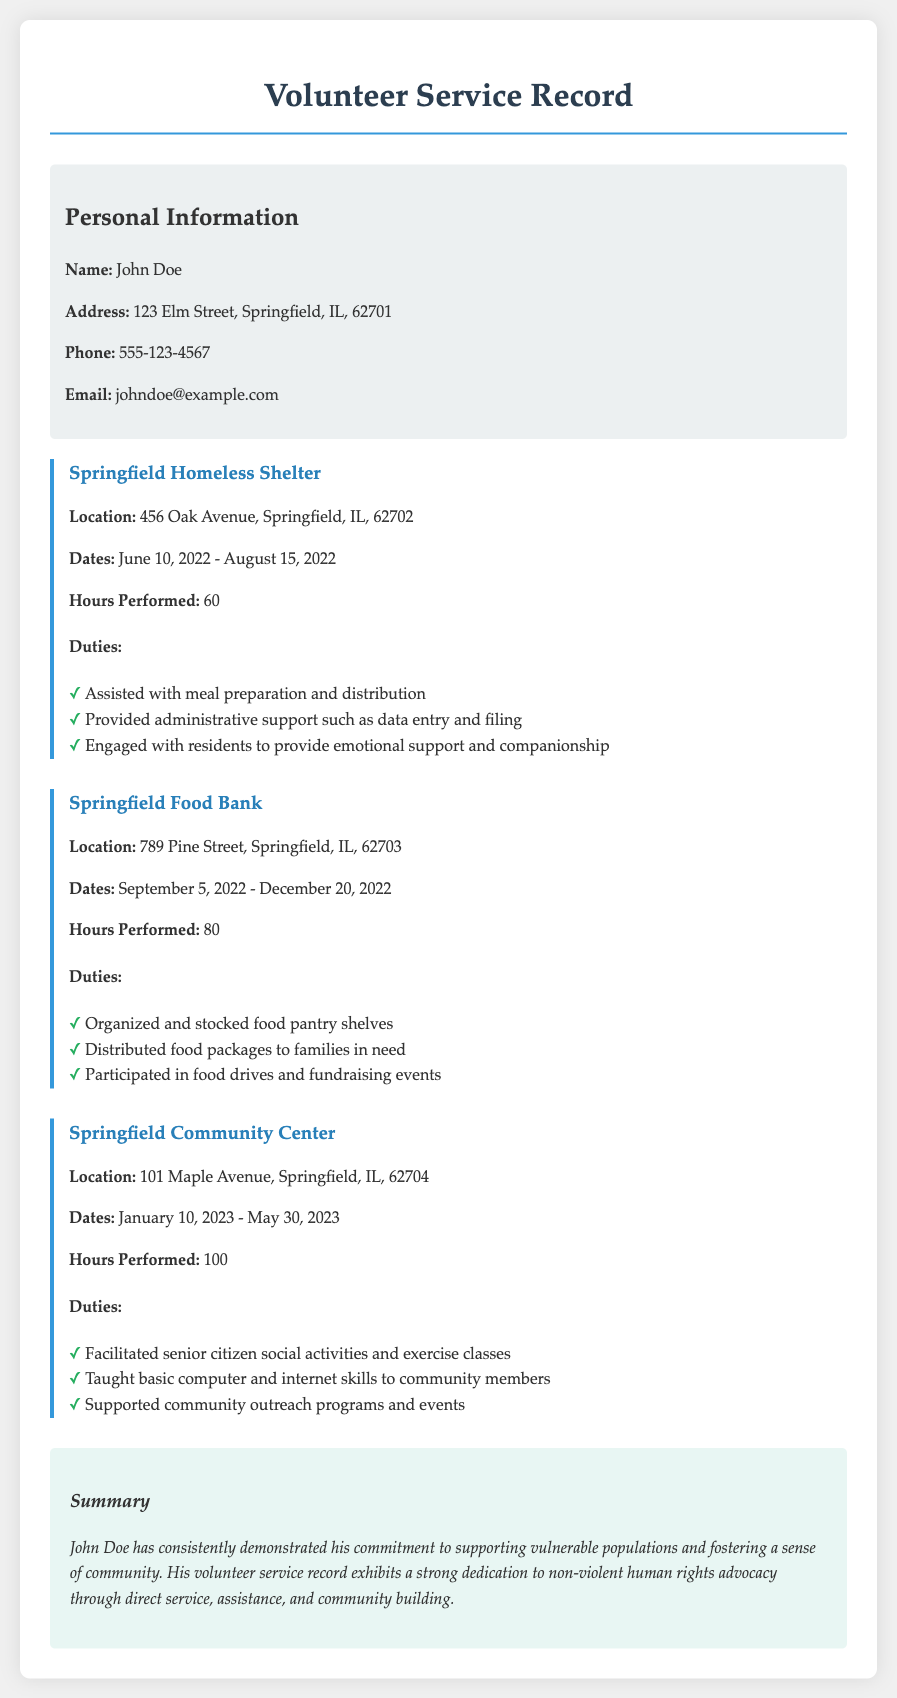What is the name of the volunteer? The name of the volunteer is stated in the personal information section of the document.
Answer: John Doe What is the address of the volunteer? The address is found in the personal information section and provides the volunteer's home location.
Answer: 123 Elm Street, Springfield, IL, 62701 How many hours were served at the Springfield Food Bank? The document states the number of hours served specifically at the Springfield Food Bank.
Answer: 80 What was one duty performed at the Springfield Homeless Shelter? The document lists specific duties performed at the Springfield Homeless Shelter, requiring identification of at least one.
Answer: Assisted with meal preparation and distribution What were the dates of service at the Springfield Community Center? The document provides the start and end dates for service at the Springfield Community Center.
Answer: January 10, 2023 - May 30, 2023 How many total hours were volunteered across all entries? This calculation involves summing the hours served at each service entry: 60 + 80 + 100.
Answer: 240 What type of supporting activities were facilitated by John Doe? This information is found in the duties listed under the Springfield Community Center service entry.
Answer: Senior citizen social activities and exercise classes What is the focus of John Doe's volunteer efforts, as summarized in the document? The summary provides insight into the overarching theme of the volunteer's service record.
Answer: Non-violent human rights advocacy 